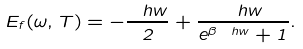Convert formula to latex. <formula><loc_0><loc_0><loc_500><loc_500>E _ { f } ( \omega , T ) = - \frac { \ h w } { 2 } + \frac { \ h w } { e ^ { \beta \ h w } + 1 } .</formula> 